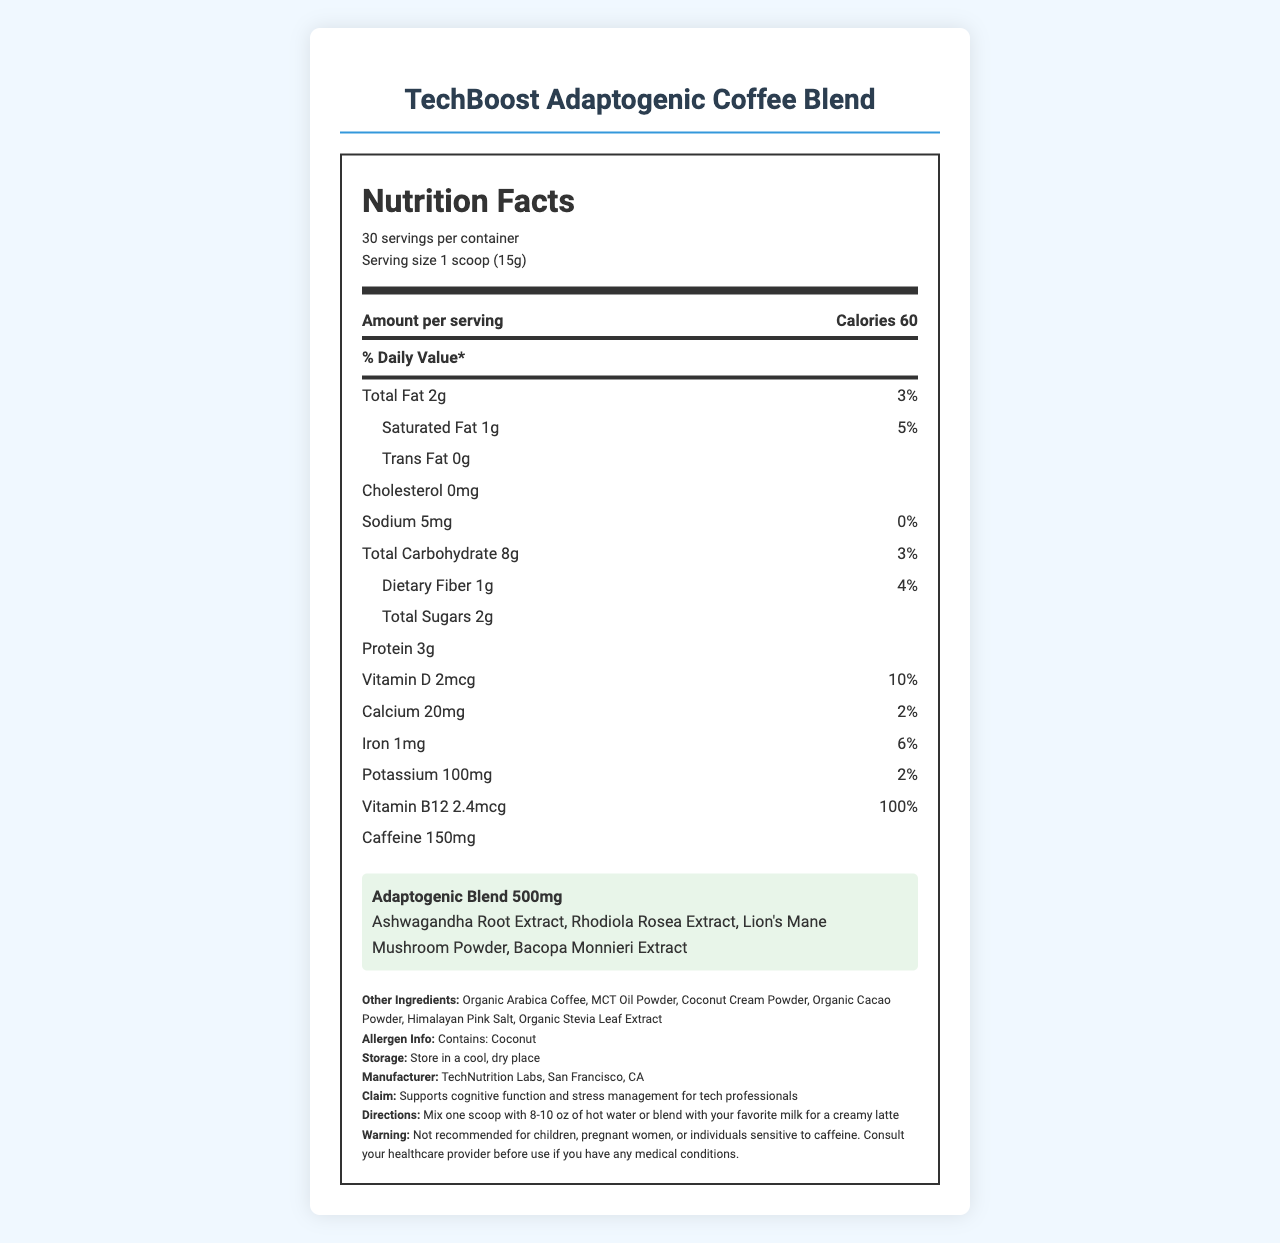what is the serving size? The serving size is listed as "1 scoop (15g)" under the serving information.
Answer: 1 scoop (15g) how many servings are there per container? The document states that there are 30 servings per container.
Answer: 30 what is the amount of calories per serving? The caloric information indicates that each serving contains 60 calories.
Answer: 60 how much total fat does one serving contain? The total fat content per serving is listed as 2g.
Answer: 2g what are the ingredients in the adaptogenic blend? The adaptogenic blend section lists these ingredients: Ashwagandha Root Extract, Rhodiola Rosea Extract, Lion's Mane Mushroom Powder, Bacopa Monnieri Extract.
Answer: Ashwagandha Root Extract, Rhodiola Rosea Extract, Lion's Mane Mushroom Powder, Bacopa Monnieri Extract what is the percentage of daily value for vitamin B12? A. 10% B. 20% C. 50% D. 100% The daily value percentage for vitamin B12 is given as 100%.
Answer: D how much sodium is present in one serving? A. 5mg B. 10mg C. 15mg D. 20mg The sodium content per serving is listed as 5mg.
Answer: A does the product contain cholesterol? The nutrient information indicates cholesterol is 0mg.
Answer: No is this product recommended for children? The warning section advises that the product is not recommended for children.
Answer: No describe the main idea of the document. The document presents detailed nutritional information, ingredient list, and usage instructions for a coffee blend designed for tech industry professionals, emphasizing its cognitive and stress management benefits.
Answer: The document is a Nutrition Facts Label for TechBoost Adaptogenic Coffee Blend aimed at supporting cognitive function and stress management for tech professionals. It includes nutritional content, ingredients, allergen information, and usage directions. who is the manufacturer of this product? The manufacturer information is listed towards the end of the document as TechNutrition Labs, San Francisco, CA.
Answer: TechNutrition Labs, San Francisco, CA how much caffeine does one serving contain? Each serving contains 150mg of caffeine, as listed in the document.
Answer: 150mg can this label identify the exact blend ratio of the adaptogenic herbs? The document provides the total amount of the adaptogenic blend and the ingredients, but it does not specify the exact ratio of each herb in the blend.
Answer: No what is the suggested way to prepare the coffee blend? The directions section suggests mixing one scoop with hot water or blending it with milk.
Answer: Mix one scoop with 8-10 oz of hot water or blend with your favorite milk for a creamy latte what is the total carbohydrate content per serving? The total carbohydrate content per serving is listed as 8g.
Answer: 8g what should you do before consuming the product if you have medical conditions? The warning advises consulting a healthcare provider if you have any medical conditions before using the product.
Answer: Consult your healthcare provider is this product free from allergens? The allergen information states that the product contains coconut.
Answer: No 